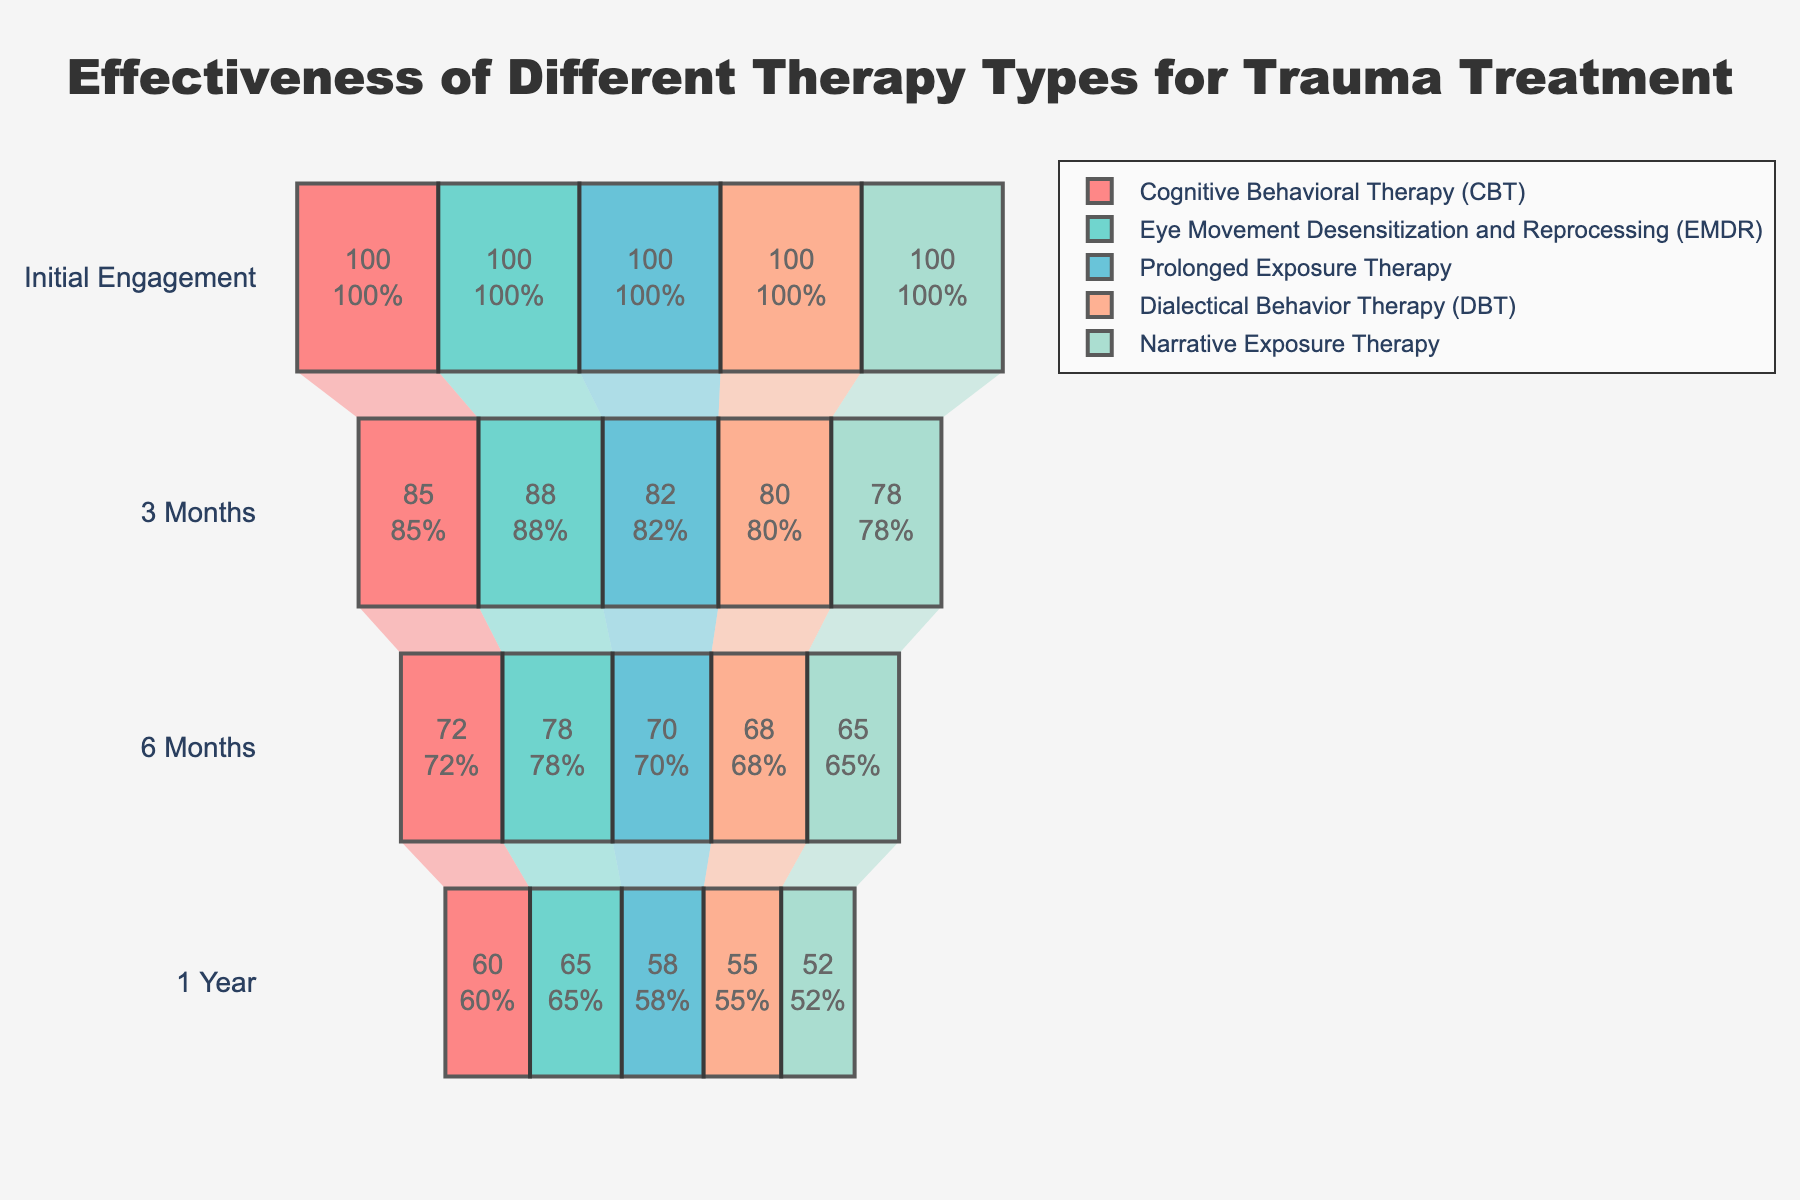What's the title of the figure? The title is usually displayed at the top of the figure. In this case, it reads "Effectiveness of Different Therapy Types for Trauma Treatment".
Answer: Effectiveness of Different Therapy Types for Trauma Treatment What is the success rate for Cognitive Behavioral Therapy (CBT) at 3 months? Locate the bar labeled "Cognitive Behavioral Therapy (CBT)" and read the value at the 3-month column. Here it shows 85%.
Answer: 85% Which therapy shows the highest success rate at 6 months? Check the success rates at the 6-month stage for all therapies and identify the highest percentage. Eye Movement Desensitization and Reprocessing (EMDR) has the highest rate at 78%.
Answer: Eye Movement Desensitization and Reprocessing (EMDR) What is the difference between the initial and 1-year success rates for Prolonged Exposure Therapy? Subtract the 1-year success rate from the initial engagement rate for Prolonged Exposure Therapy. The initial rate is 100 and the 1-year rate is 58, so the difference is 100 - 58.
Answer: 42 Which therapy type has the least drop in success rate from 3 months to 6 months? Calculate the difference between the 3-month and 6-month success rates for each therapy and identify the one with the smallest drop. For EMDR, the drop is 88 - 78 = 10, which is the smallest among the therapies.
Answer: Eye Movement Desensitization and Reprocessing (EMDR) What is the average success rate at 1 year across all therapies? Add the success rates at the 1-year mark for all five therapies and divide by the number of therapies. (60+65+58+55+52)/5 equals 58.
Answer: 58 How does Dialectical Behavior Therapy (DBT) compare to Narrative Exposure Therapy at 1 year? Compare the success rates for DBT and Narrative Exposure Therapy at the 1-year mark. DBT has a rate of 55% and Narrative Exposure Therapy has 52%, so DBT is higher.
Answer: DBT is higher What therapy type maintains the highest retention rate at 3 months relative to the initial engagement? The retention rate can be calculated as the percentage of the initial engagement at 3 months. EMDR maintains 88% of its initial engagement at 3 months, which is the highest among the therapies.
Answer: Eye Movement Desensitization and Reprocessing (EMDR) How many therapy types show a success rate over 70% at 6 months? Check the success rates at the 6-month stage and count the therapies with rates higher than 70%. CBT and EMDR both show rates over 70%.
Answer: 2 